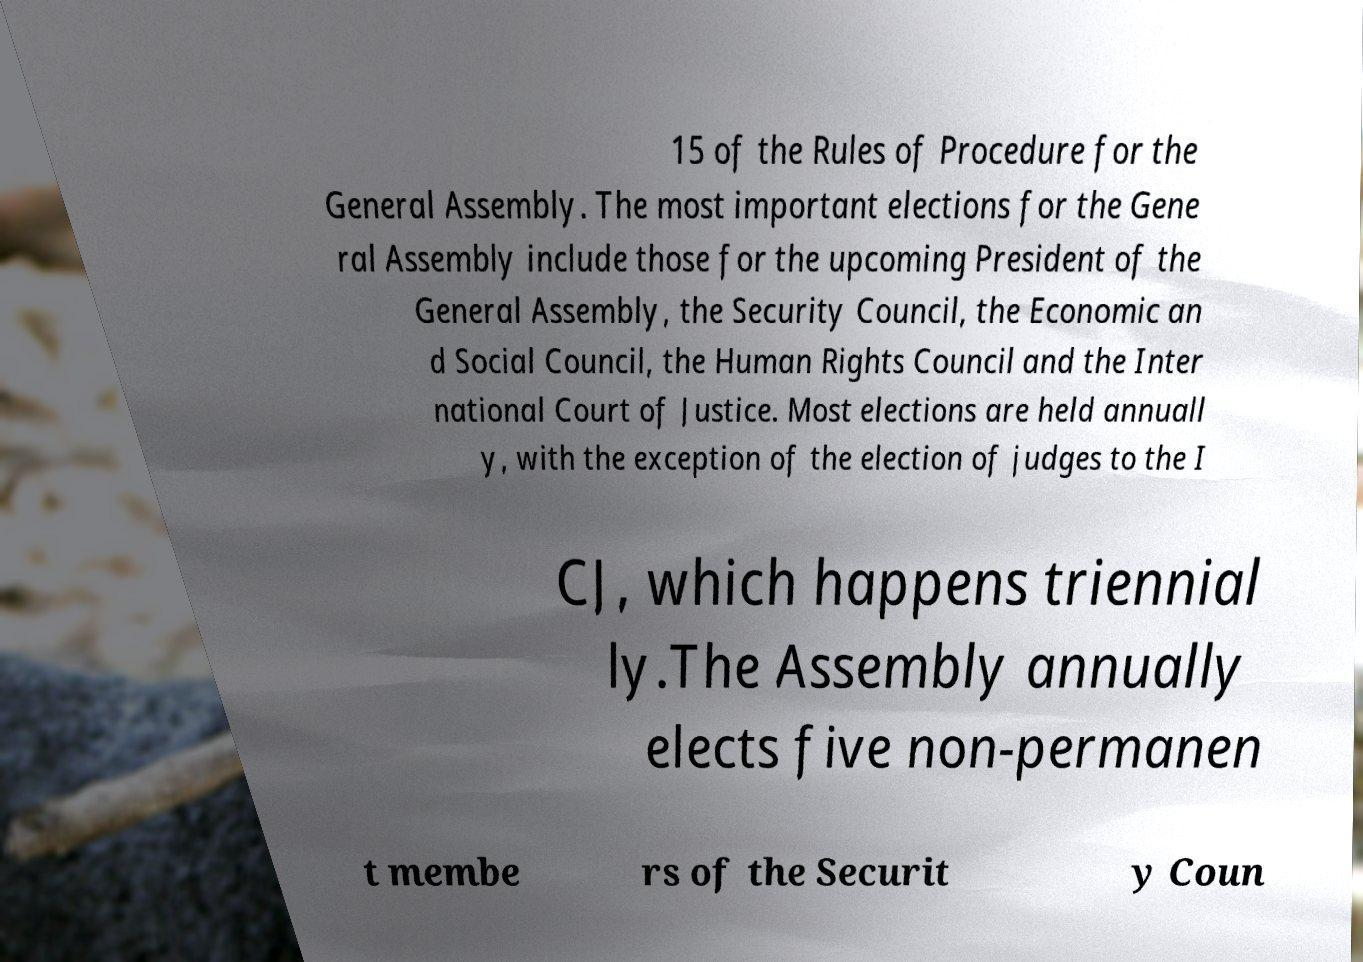What messages or text are displayed in this image? I need them in a readable, typed format. 15 of the Rules of Procedure for the General Assembly. The most important elections for the Gene ral Assembly include those for the upcoming President of the General Assembly, the Security Council, the Economic an d Social Council, the Human Rights Council and the Inter national Court of Justice. Most elections are held annuall y, with the exception of the election of judges to the I CJ, which happens triennial ly.The Assembly annually elects five non-permanen t membe rs of the Securit y Coun 